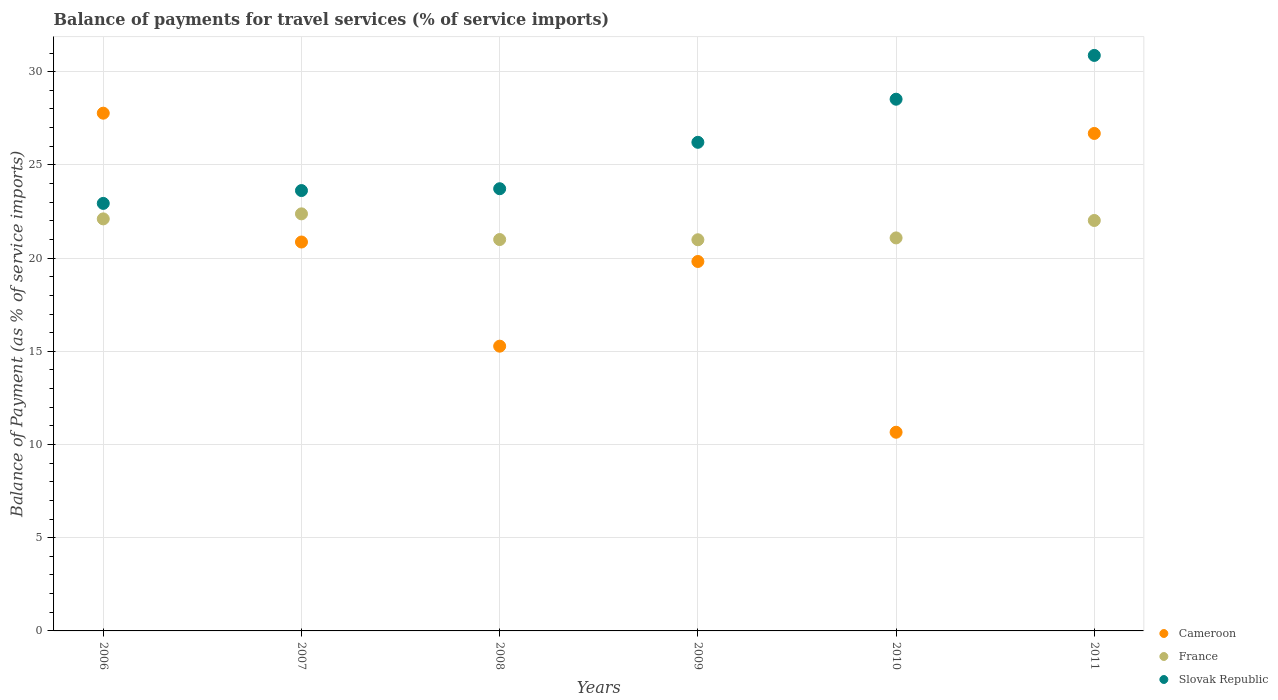Is the number of dotlines equal to the number of legend labels?
Your answer should be compact. Yes. What is the balance of payments for travel services in Cameroon in 2008?
Offer a very short reply. 15.27. Across all years, what is the maximum balance of payments for travel services in France?
Ensure brevity in your answer.  22.37. Across all years, what is the minimum balance of payments for travel services in France?
Your answer should be very brief. 20.98. In which year was the balance of payments for travel services in Slovak Republic minimum?
Keep it short and to the point. 2006. What is the total balance of payments for travel services in France in the graph?
Provide a short and direct response. 129.55. What is the difference between the balance of payments for travel services in France in 2006 and that in 2008?
Give a very brief answer. 1.11. What is the difference between the balance of payments for travel services in Slovak Republic in 2011 and the balance of payments for travel services in Cameroon in 2008?
Provide a short and direct response. 15.6. What is the average balance of payments for travel services in France per year?
Your answer should be very brief. 21.59. In the year 2007, what is the difference between the balance of payments for travel services in France and balance of payments for travel services in Cameroon?
Provide a short and direct response. 1.51. In how many years, is the balance of payments for travel services in Slovak Republic greater than 20 %?
Make the answer very short. 6. What is the ratio of the balance of payments for travel services in Slovak Republic in 2009 to that in 2010?
Offer a terse response. 0.92. Is the balance of payments for travel services in France in 2007 less than that in 2008?
Make the answer very short. No. Is the difference between the balance of payments for travel services in France in 2010 and 2011 greater than the difference between the balance of payments for travel services in Cameroon in 2010 and 2011?
Provide a succinct answer. Yes. What is the difference between the highest and the second highest balance of payments for travel services in Cameroon?
Provide a succinct answer. 1.09. What is the difference between the highest and the lowest balance of payments for travel services in Slovak Republic?
Keep it short and to the point. 7.94. In how many years, is the balance of payments for travel services in France greater than the average balance of payments for travel services in France taken over all years?
Ensure brevity in your answer.  3. Is the sum of the balance of payments for travel services in France in 2007 and 2011 greater than the maximum balance of payments for travel services in Slovak Republic across all years?
Provide a succinct answer. Yes. Is it the case that in every year, the sum of the balance of payments for travel services in Slovak Republic and balance of payments for travel services in Cameroon  is greater than the balance of payments for travel services in France?
Ensure brevity in your answer.  Yes. How many dotlines are there?
Your response must be concise. 3. What is the difference between two consecutive major ticks on the Y-axis?
Keep it short and to the point. 5. Are the values on the major ticks of Y-axis written in scientific E-notation?
Ensure brevity in your answer.  No. Where does the legend appear in the graph?
Your answer should be compact. Bottom right. What is the title of the graph?
Your answer should be very brief. Balance of payments for travel services (% of service imports). What is the label or title of the X-axis?
Your answer should be compact. Years. What is the label or title of the Y-axis?
Your response must be concise. Balance of Payment (as % of service imports). What is the Balance of Payment (as % of service imports) of Cameroon in 2006?
Offer a terse response. 27.77. What is the Balance of Payment (as % of service imports) in France in 2006?
Give a very brief answer. 22.1. What is the Balance of Payment (as % of service imports) of Slovak Republic in 2006?
Give a very brief answer. 22.93. What is the Balance of Payment (as % of service imports) in Cameroon in 2007?
Give a very brief answer. 20.86. What is the Balance of Payment (as % of service imports) in France in 2007?
Your response must be concise. 22.37. What is the Balance of Payment (as % of service imports) of Slovak Republic in 2007?
Your answer should be compact. 23.62. What is the Balance of Payment (as % of service imports) in Cameroon in 2008?
Your response must be concise. 15.27. What is the Balance of Payment (as % of service imports) of France in 2008?
Provide a succinct answer. 20.99. What is the Balance of Payment (as % of service imports) of Slovak Republic in 2008?
Ensure brevity in your answer.  23.72. What is the Balance of Payment (as % of service imports) in Cameroon in 2009?
Provide a succinct answer. 19.82. What is the Balance of Payment (as % of service imports) of France in 2009?
Provide a short and direct response. 20.98. What is the Balance of Payment (as % of service imports) in Slovak Republic in 2009?
Provide a succinct answer. 26.21. What is the Balance of Payment (as % of service imports) of Cameroon in 2010?
Provide a succinct answer. 10.66. What is the Balance of Payment (as % of service imports) in France in 2010?
Offer a terse response. 21.08. What is the Balance of Payment (as % of service imports) of Slovak Republic in 2010?
Offer a terse response. 28.52. What is the Balance of Payment (as % of service imports) in Cameroon in 2011?
Give a very brief answer. 26.69. What is the Balance of Payment (as % of service imports) of France in 2011?
Your answer should be very brief. 22.02. What is the Balance of Payment (as % of service imports) of Slovak Republic in 2011?
Your answer should be very brief. 30.87. Across all years, what is the maximum Balance of Payment (as % of service imports) in Cameroon?
Provide a succinct answer. 27.77. Across all years, what is the maximum Balance of Payment (as % of service imports) in France?
Offer a very short reply. 22.37. Across all years, what is the maximum Balance of Payment (as % of service imports) of Slovak Republic?
Keep it short and to the point. 30.87. Across all years, what is the minimum Balance of Payment (as % of service imports) of Cameroon?
Keep it short and to the point. 10.66. Across all years, what is the minimum Balance of Payment (as % of service imports) in France?
Your answer should be compact. 20.98. Across all years, what is the minimum Balance of Payment (as % of service imports) of Slovak Republic?
Offer a very short reply. 22.93. What is the total Balance of Payment (as % of service imports) of Cameroon in the graph?
Provide a succinct answer. 121.07. What is the total Balance of Payment (as % of service imports) of France in the graph?
Provide a short and direct response. 129.55. What is the total Balance of Payment (as % of service imports) in Slovak Republic in the graph?
Your response must be concise. 155.88. What is the difference between the Balance of Payment (as % of service imports) of Cameroon in 2006 and that in 2007?
Give a very brief answer. 6.91. What is the difference between the Balance of Payment (as % of service imports) of France in 2006 and that in 2007?
Offer a very short reply. -0.27. What is the difference between the Balance of Payment (as % of service imports) of Slovak Republic in 2006 and that in 2007?
Keep it short and to the point. -0.69. What is the difference between the Balance of Payment (as % of service imports) in Cameroon in 2006 and that in 2008?
Offer a very short reply. 12.5. What is the difference between the Balance of Payment (as % of service imports) in France in 2006 and that in 2008?
Make the answer very short. 1.11. What is the difference between the Balance of Payment (as % of service imports) in Slovak Republic in 2006 and that in 2008?
Your response must be concise. -0.79. What is the difference between the Balance of Payment (as % of service imports) of Cameroon in 2006 and that in 2009?
Make the answer very short. 7.96. What is the difference between the Balance of Payment (as % of service imports) of France in 2006 and that in 2009?
Your answer should be very brief. 1.12. What is the difference between the Balance of Payment (as % of service imports) of Slovak Republic in 2006 and that in 2009?
Your response must be concise. -3.28. What is the difference between the Balance of Payment (as % of service imports) of Cameroon in 2006 and that in 2010?
Ensure brevity in your answer.  17.11. What is the difference between the Balance of Payment (as % of service imports) in France in 2006 and that in 2010?
Your answer should be very brief. 1.02. What is the difference between the Balance of Payment (as % of service imports) in Slovak Republic in 2006 and that in 2010?
Provide a succinct answer. -5.59. What is the difference between the Balance of Payment (as % of service imports) in Cameroon in 2006 and that in 2011?
Ensure brevity in your answer.  1.09. What is the difference between the Balance of Payment (as % of service imports) in France in 2006 and that in 2011?
Provide a succinct answer. 0.09. What is the difference between the Balance of Payment (as % of service imports) in Slovak Republic in 2006 and that in 2011?
Offer a terse response. -7.94. What is the difference between the Balance of Payment (as % of service imports) of Cameroon in 2007 and that in 2008?
Your answer should be very brief. 5.59. What is the difference between the Balance of Payment (as % of service imports) in France in 2007 and that in 2008?
Provide a succinct answer. 1.38. What is the difference between the Balance of Payment (as % of service imports) of Slovak Republic in 2007 and that in 2008?
Offer a very short reply. -0.1. What is the difference between the Balance of Payment (as % of service imports) of Cameroon in 2007 and that in 2009?
Give a very brief answer. 1.04. What is the difference between the Balance of Payment (as % of service imports) in France in 2007 and that in 2009?
Your answer should be compact. 1.39. What is the difference between the Balance of Payment (as % of service imports) in Slovak Republic in 2007 and that in 2009?
Keep it short and to the point. -2.59. What is the difference between the Balance of Payment (as % of service imports) in Cameroon in 2007 and that in 2010?
Make the answer very short. 10.2. What is the difference between the Balance of Payment (as % of service imports) in France in 2007 and that in 2010?
Offer a terse response. 1.29. What is the difference between the Balance of Payment (as % of service imports) of Slovak Republic in 2007 and that in 2010?
Offer a terse response. -4.9. What is the difference between the Balance of Payment (as % of service imports) of Cameroon in 2007 and that in 2011?
Offer a very short reply. -5.82. What is the difference between the Balance of Payment (as % of service imports) in France in 2007 and that in 2011?
Your answer should be very brief. 0.36. What is the difference between the Balance of Payment (as % of service imports) in Slovak Republic in 2007 and that in 2011?
Offer a terse response. -7.25. What is the difference between the Balance of Payment (as % of service imports) of Cameroon in 2008 and that in 2009?
Provide a short and direct response. -4.54. What is the difference between the Balance of Payment (as % of service imports) in France in 2008 and that in 2009?
Offer a terse response. 0.01. What is the difference between the Balance of Payment (as % of service imports) in Slovak Republic in 2008 and that in 2009?
Offer a terse response. -2.49. What is the difference between the Balance of Payment (as % of service imports) in Cameroon in 2008 and that in 2010?
Offer a terse response. 4.62. What is the difference between the Balance of Payment (as % of service imports) of France in 2008 and that in 2010?
Provide a succinct answer. -0.09. What is the difference between the Balance of Payment (as % of service imports) in Slovak Republic in 2008 and that in 2010?
Keep it short and to the point. -4.8. What is the difference between the Balance of Payment (as % of service imports) in Cameroon in 2008 and that in 2011?
Keep it short and to the point. -11.41. What is the difference between the Balance of Payment (as % of service imports) of France in 2008 and that in 2011?
Ensure brevity in your answer.  -1.02. What is the difference between the Balance of Payment (as % of service imports) of Slovak Republic in 2008 and that in 2011?
Make the answer very short. -7.15. What is the difference between the Balance of Payment (as % of service imports) in Cameroon in 2009 and that in 2010?
Keep it short and to the point. 9.16. What is the difference between the Balance of Payment (as % of service imports) of France in 2009 and that in 2010?
Your answer should be compact. -0.1. What is the difference between the Balance of Payment (as % of service imports) in Slovak Republic in 2009 and that in 2010?
Give a very brief answer. -2.31. What is the difference between the Balance of Payment (as % of service imports) of Cameroon in 2009 and that in 2011?
Your answer should be very brief. -6.87. What is the difference between the Balance of Payment (as % of service imports) of France in 2009 and that in 2011?
Give a very brief answer. -1.03. What is the difference between the Balance of Payment (as % of service imports) of Slovak Republic in 2009 and that in 2011?
Ensure brevity in your answer.  -4.66. What is the difference between the Balance of Payment (as % of service imports) in Cameroon in 2010 and that in 2011?
Give a very brief answer. -16.03. What is the difference between the Balance of Payment (as % of service imports) in France in 2010 and that in 2011?
Your answer should be very brief. -0.93. What is the difference between the Balance of Payment (as % of service imports) in Slovak Republic in 2010 and that in 2011?
Your answer should be compact. -2.35. What is the difference between the Balance of Payment (as % of service imports) of Cameroon in 2006 and the Balance of Payment (as % of service imports) of France in 2007?
Offer a terse response. 5.4. What is the difference between the Balance of Payment (as % of service imports) in Cameroon in 2006 and the Balance of Payment (as % of service imports) in Slovak Republic in 2007?
Provide a succinct answer. 4.15. What is the difference between the Balance of Payment (as % of service imports) of France in 2006 and the Balance of Payment (as % of service imports) of Slovak Republic in 2007?
Offer a terse response. -1.52. What is the difference between the Balance of Payment (as % of service imports) of Cameroon in 2006 and the Balance of Payment (as % of service imports) of France in 2008?
Make the answer very short. 6.78. What is the difference between the Balance of Payment (as % of service imports) of Cameroon in 2006 and the Balance of Payment (as % of service imports) of Slovak Republic in 2008?
Your response must be concise. 4.05. What is the difference between the Balance of Payment (as % of service imports) in France in 2006 and the Balance of Payment (as % of service imports) in Slovak Republic in 2008?
Ensure brevity in your answer.  -1.62. What is the difference between the Balance of Payment (as % of service imports) in Cameroon in 2006 and the Balance of Payment (as % of service imports) in France in 2009?
Your answer should be compact. 6.79. What is the difference between the Balance of Payment (as % of service imports) in Cameroon in 2006 and the Balance of Payment (as % of service imports) in Slovak Republic in 2009?
Your response must be concise. 1.56. What is the difference between the Balance of Payment (as % of service imports) in France in 2006 and the Balance of Payment (as % of service imports) in Slovak Republic in 2009?
Offer a very short reply. -4.11. What is the difference between the Balance of Payment (as % of service imports) of Cameroon in 2006 and the Balance of Payment (as % of service imports) of France in 2010?
Your answer should be compact. 6.69. What is the difference between the Balance of Payment (as % of service imports) in Cameroon in 2006 and the Balance of Payment (as % of service imports) in Slovak Republic in 2010?
Make the answer very short. -0.75. What is the difference between the Balance of Payment (as % of service imports) of France in 2006 and the Balance of Payment (as % of service imports) of Slovak Republic in 2010?
Offer a very short reply. -6.42. What is the difference between the Balance of Payment (as % of service imports) of Cameroon in 2006 and the Balance of Payment (as % of service imports) of France in 2011?
Make the answer very short. 5.76. What is the difference between the Balance of Payment (as % of service imports) in Cameroon in 2006 and the Balance of Payment (as % of service imports) in Slovak Republic in 2011?
Make the answer very short. -3.1. What is the difference between the Balance of Payment (as % of service imports) in France in 2006 and the Balance of Payment (as % of service imports) in Slovak Republic in 2011?
Offer a very short reply. -8.77. What is the difference between the Balance of Payment (as % of service imports) of Cameroon in 2007 and the Balance of Payment (as % of service imports) of France in 2008?
Provide a short and direct response. -0.13. What is the difference between the Balance of Payment (as % of service imports) in Cameroon in 2007 and the Balance of Payment (as % of service imports) in Slovak Republic in 2008?
Keep it short and to the point. -2.86. What is the difference between the Balance of Payment (as % of service imports) of France in 2007 and the Balance of Payment (as % of service imports) of Slovak Republic in 2008?
Your response must be concise. -1.35. What is the difference between the Balance of Payment (as % of service imports) of Cameroon in 2007 and the Balance of Payment (as % of service imports) of France in 2009?
Your answer should be compact. -0.12. What is the difference between the Balance of Payment (as % of service imports) of Cameroon in 2007 and the Balance of Payment (as % of service imports) of Slovak Republic in 2009?
Provide a short and direct response. -5.35. What is the difference between the Balance of Payment (as % of service imports) in France in 2007 and the Balance of Payment (as % of service imports) in Slovak Republic in 2009?
Make the answer very short. -3.84. What is the difference between the Balance of Payment (as % of service imports) of Cameroon in 2007 and the Balance of Payment (as % of service imports) of France in 2010?
Offer a terse response. -0.22. What is the difference between the Balance of Payment (as % of service imports) of Cameroon in 2007 and the Balance of Payment (as % of service imports) of Slovak Republic in 2010?
Your answer should be very brief. -7.66. What is the difference between the Balance of Payment (as % of service imports) of France in 2007 and the Balance of Payment (as % of service imports) of Slovak Republic in 2010?
Provide a succinct answer. -6.15. What is the difference between the Balance of Payment (as % of service imports) in Cameroon in 2007 and the Balance of Payment (as % of service imports) in France in 2011?
Make the answer very short. -1.16. What is the difference between the Balance of Payment (as % of service imports) of Cameroon in 2007 and the Balance of Payment (as % of service imports) of Slovak Republic in 2011?
Your response must be concise. -10.01. What is the difference between the Balance of Payment (as % of service imports) of France in 2007 and the Balance of Payment (as % of service imports) of Slovak Republic in 2011?
Your response must be concise. -8.5. What is the difference between the Balance of Payment (as % of service imports) in Cameroon in 2008 and the Balance of Payment (as % of service imports) in France in 2009?
Offer a very short reply. -5.71. What is the difference between the Balance of Payment (as % of service imports) of Cameroon in 2008 and the Balance of Payment (as % of service imports) of Slovak Republic in 2009?
Your response must be concise. -10.94. What is the difference between the Balance of Payment (as % of service imports) in France in 2008 and the Balance of Payment (as % of service imports) in Slovak Republic in 2009?
Ensure brevity in your answer.  -5.22. What is the difference between the Balance of Payment (as % of service imports) in Cameroon in 2008 and the Balance of Payment (as % of service imports) in France in 2010?
Keep it short and to the point. -5.81. What is the difference between the Balance of Payment (as % of service imports) of Cameroon in 2008 and the Balance of Payment (as % of service imports) of Slovak Republic in 2010?
Your response must be concise. -13.25. What is the difference between the Balance of Payment (as % of service imports) of France in 2008 and the Balance of Payment (as % of service imports) of Slovak Republic in 2010?
Your answer should be very brief. -7.53. What is the difference between the Balance of Payment (as % of service imports) in Cameroon in 2008 and the Balance of Payment (as % of service imports) in France in 2011?
Offer a terse response. -6.74. What is the difference between the Balance of Payment (as % of service imports) of Cameroon in 2008 and the Balance of Payment (as % of service imports) of Slovak Republic in 2011?
Provide a short and direct response. -15.6. What is the difference between the Balance of Payment (as % of service imports) in France in 2008 and the Balance of Payment (as % of service imports) in Slovak Republic in 2011?
Offer a very short reply. -9.88. What is the difference between the Balance of Payment (as % of service imports) of Cameroon in 2009 and the Balance of Payment (as % of service imports) of France in 2010?
Provide a short and direct response. -1.26. What is the difference between the Balance of Payment (as % of service imports) of Cameroon in 2009 and the Balance of Payment (as % of service imports) of Slovak Republic in 2010?
Your response must be concise. -8.7. What is the difference between the Balance of Payment (as % of service imports) of France in 2009 and the Balance of Payment (as % of service imports) of Slovak Republic in 2010?
Provide a short and direct response. -7.54. What is the difference between the Balance of Payment (as % of service imports) in Cameroon in 2009 and the Balance of Payment (as % of service imports) in France in 2011?
Provide a short and direct response. -2.2. What is the difference between the Balance of Payment (as % of service imports) of Cameroon in 2009 and the Balance of Payment (as % of service imports) of Slovak Republic in 2011?
Your answer should be very brief. -11.05. What is the difference between the Balance of Payment (as % of service imports) of France in 2009 and the Balance of Payment (as % of service imports) of Slovak Republic in 2011?
Your answer should be compact. -9.89. What is the difference between the Balance of Payment (as % of service imports) in Cameroon in 2010 and the Balance of Payment (as % of service imports) in France in 2011?
Your answer should be very brief. -11.36. What is the difference between the Balance of Payment (as % of service imports) in Cameroon in 2010 and the Balance of Payment (as % of service imports) in Slovak Republic in 2011?
Provide a short and direct response. -20.21. What is the difference between the Balance of Payment (as % of service imports) of France in 2010 and the Balance of Payment (as % of service imports) of Slovak Republic in 2011?
Offer a very short reply. -9.79. What is the average Balance of Payment (as % of service imports) of Cameroon per year?
Give a very brief answer. 20.18. What is the average Balance of Payment (as % of service imports) in France per year?
Offer a terse response. 21.59. What is the average Balance of Payment (as % of service imports) in Slovak Republic per year?
Make the answer very short. 25.98. In the year 2006, what is the difference between the Balance of Payment (as % of service imports) in Cameroon and Balance of Payment (as % of service imports) in France?
Your response must be concise. 5.67. In the year 2006, what is the difference between the Balance of Payment (as % of service imports) in Cameroon and Balance of Payment (as % of service imports) in Slovak Republic?
Your answer should be very brief. 4.84. In the year 2006, what is the difference between the Balance of Payment (as % of service imports) of France and Balance of Payment (as % of service imports) of Slovak Republic?
Your answer should be compact. -0.83. In the year 2007, what is the difference between the Balance of Payment (as % of service imports) in Cameroon and Balance of Payment (as % of service imports) in France?
Your response must be concise. -1.51. In the year 2007, what is the difference between the Balance of Payment (as % of service imports) of Cameroon and Balance of Payment (as % of service imports) of Slovak Republic?
Offer a very short reply. -2.76. In the year 2007, what is the difference between the Balance of Payment (as % of service imports) of France and Balance of Payment (as % of service imports) of Slovak Republic?
Keep it short and to the point. -1.25. In the year 2008, what is the difference between the Balance of Payment (as % of service imports) of Cameroon and Balance of Payment (as % of service imports) of France?
Make the answer very short. -5.72. In the year 2008, what is the difference between the Balance of Payment (as % of service imports) of Cameroon and Balance of Payment (as % of service imports) of Slovak Republic?
Offer a very short reply. -8.45. In the year 2008, what is the difference between the Balance of Payment (as % of service imports) in France and Balance of Payment (as % of service imports) in Slovak Republic?
Offer a terse response. -2.73. In the year 2009, what is the difference between the Balance of Payment (as % of service imports) of Cameroon and Balance of Payment (as % of service imports) of France?
Offer a very short reply. -1.17. In the year 2009, what is the difference between the Balance of Payment (as % of service imports) of Cameroon and Balance of Payment (as % of service imports) of Slovak Republic?
Your answer should be compact. -6.39. In the year 2009, what is the difference between the Balance of Payment (as % of service imports) of France and Balance of Payment (as % of service imports) of Slovak Republic?
Keep it short and to the point. -5.23. In the year 2010, what is the difference between the Balance of Payment (as % of service imports) of Cameroon and Balance of Payment (as % of service imports) of France?
Offer a terse response. -10.42. In the year 2010, what is the difference between the Balance of Payment (as % of service imports) in Cameroon and Balance of Payment (as % of service imports) in Slovak Republic?
Provide a succinct answer. -17.86. In the year 2010, what is the difference between the Balance of Payment (as % of service imports) of France and Balance of Payment (as % of service imports) of Slovak Republic?
Offer a terse response. -7.44. In the year 2011, what is the difference between the Balance of Payment (as % of service imports) of Cameroon and Balance of Payment (as % of service imports) of France?
Give a very brief answer. 4.67. In the year 2011, what is the difference between the Balance of Payment (as % of service imports) in Cameroon and Balance of Payment (as % of service imports) in Slovak Republic?
Offer a terse response. -4.19. In the year 2011, what is the difference between the Balance of Payment (as % of service imports) in France and Balance of Payment (as % of service imports) in Slovak Republic?
Give a very brief answer. -8.85. What is the ratio of the Balance of Payment (as % of service imports) of Cameroon in 2006 to that in 2007?
Your response must be concise. 1.33. What is the ratio of the Balance of Payment (as % of service imports) in France in 2006 to that in 2007?
Make the answer very short. 0.99. What is the ratio of the Balance of Payment (as % of service imports) of Slovak Republic in 2006 to that in 2007?
Your answer should be very brief. 0.97. What is the ratio of the Balance of Payment (as % of service imports) in Cameroon in 2006 to that in 2008?
Keep it short and to the point. 1.82. What is the ratio of the Balance of Payment (as % of service imports) in France in 2006 to that in 2008?
Give a very brief answer. 1.05. What is the ratio of the Balance of Payment (as % of service imports) of Slovak Republic in 2006 to that in 2008?
Provide a short and direct response. 0.97. What is the ratio of the Balance of Payment (as % of service imports) in Cameroon in 2006 to that in 2009?
Offer a terse response. 1.4. What is the ratio of the Balance of Payment (as % of service imports) in France in 2006 to that in 2009?
Give a very brief answer. 1.05. What is the ratio of the Balance of Payment (as % of service imports) of Slovak Republic in 2006 to that in 2009?
Your answer should be very brief. 0.88. What is the ratio of the Balance of Payment (as % of service imports) in Cameroon in 2006 to that in 2010?
Ensure brevity in your answer.  2.61. What is the ratio of the Balance of Payment (as % of service imports) of France in 2006 to that in 2010?
Offer a terse response. 1.05. What is the ratio of the Balance of Payment (as % of service imports) of Slovak Republic in 2006 to that in 2010?
Make the answer very short. 0.8. What is the ratio of the Balance of Payment (as % of service imports) in Cameroon in 2006 to that in 2011?
Make the answer very short. 1.04. What is the ratio of the Balance of Payment (as % of service imports) in France in 2006 to that in 2011?
Your answer should be very brief. 1. What is the ratio of the Balance of Payment (as % of service imports) in Slovak Republic in 2006 to that in 2011?
Ensure brevity in your answer.  0.74. What is the ratio of the Balance of Payment (as % of service imports) in Cameroon in 2007 to that in 2008?
Offer a very short reply. 1.37. What is the ratio of the Balance of Payment (as % of service imports) of France in 2007 to that in 2008?
Your response must be concise. 1.07. What is the ratio of the Balance of Payment (as % of service imports) in Slovak Republic in 2007 to that in 2008?
Give a very brief answer. 1. What is the ratio of the Balance of Payment (as % of service imports) of Cameroon in 2007 to that in 2009?
Give a very brief answer. 1.05. What is the ratio of the Balance of Payment (as % of service imports) of France in 2007 to that in 2009?
Make the answer very short. 1.07. What is the ratio of the Balance of Payment (as % of service imports) in Slovak Republic in 2007 to that in 2009?
Offer a very short reply. 0.9. What is the ratio of the Balance of Payment (as % of service imports) of Cameroon in 2007 to that in 2010?
Offer a terse response. 1.96. What is the ratio of the Balance of Payment (as % of service imports) of France in 2007 to that in 2010?
Provide a short and direct response. 1.06. What is the ratio of the Balance of Payment (as % of service imports) in Slovak Republic in 2007 to that in 2010?
Ensure brevity in your answer.  0.83. What is the ratio of the Balance of Payment (as % of service imports) of Cameroon in 2007 to that in 2011?
Provide a succinct answer. 0.78. What is the ratio of the Balance of Payment (as % of service imports) of France in 2007 to that in 2011?
Offer a terse response. 1.02. What is the ratio of the Balance of Payment (as % of service imports) of Slovak Republic in 2007 to that in 2011?
Provide a short and direct response. 0.77. What is the ratio of the Balance of Payment (as % of service imports) in Cameroon in 2008 to that in 2009?
Offer a very short reply. 0.77. What is the ratio of the Balance of Payment (as % of service imports) in Slovak Republic in 2008 to that in 2009?
Give a very brief answer. 0.91. What is the ratio of the Balance of Payment (as % of service imports) of Cameroon in 2008 to that in 2010?
Ensure brevity in your answer.  1.43. What is the ratio of the Balance of Payment (as % of service imports) of France in 2008 to that in 2010?
Ensure brevity in your answer.  1. What is the ratio of the Balance of Payment (as % of service imports) of Slovak Republic in 2008 to that in 2010?
Offer a very short reply. 0.83. What is the ratio of the Balance of Payment (as % of service imports) of Cameroon in 2008 to that in 2011?
Provide a succinct answer. 0.57. What is the ratio of the Balance of Payment (as % of service imports) of France in 2008 to that in 2011?
Give a very brief answer. 0.95. What is the ratio of the Balance of Payment (as % of service imports) in Slovak Republic in 2008 to that in 2011?
Give a very brief answer. 0.77. What is the ratio of the Balance of Payment (as % of service imports) of Cameroon in 2009 to that in 2010?
Give a very brief answer. 1.86. What is the ratio of the Balance of Payment (as % of service imports) in France in 2009 to that in 2010?
Your response must be concise. 1. What is the ratio of the Balance of Payment (as % of service imports) in Slovak Republic in 2009 to that in 2010?
Your answer should be very brief. 0.92. What is the ratio of the Balance of Payment (as % of service imports) of Cameroon in 2009 to that in 2011?
Make the answer very short. 0.74. What is the ratio of the Balance of Payment (as % of service imports) of France in 2009 to that in 2011?
Give a very brief answer. 0.95. What is the ratio of the Balance of Payment (as % of service imports) in Slovak Republic in 2009 to that in 2011?
Offer a very short reply. 0.85. What is the ratio of the Balance of Payment (as % of service imports) in Cameroon in 2010 to that in 2011?
Your answer should be compact. 0.4. What is the ratio of the Balance of Payment (as % of service imports) of France in 2010 to that in 2011?
Keep it short and to the point. 0.96. What is the ratio of the Balance of Payment (as % of service imports) in Slovak Republic in 2010 to that in 2011?
Give a very brief answer. 0.92. What is the difference between the highest and the second highest Balance of Payment (as % of service imports) in Cameroon?
Keep it short and to the point. 1.09. What is the difference between the highest and the second highest Balance of Payment (as % of service imports) of France?
Provide a succinct answer. 0.27. What is the difference between the highest and the second highest Balance of Payment (as % of service imports) of Slovak Republic?
Your answer should be very brief. 2.35. What is the difference between the highest and the lowest Balance of Payment (as % of service imports) in Cameroon?
Your response must be concise. 17.11. What is the difference between the highest and the lowest Balance of Payment (as % of service imports) in France?
Ensure brevity in your answer.  1.39. What is the difference between the highest and the lowest Balance of Payment (as % of service imports) of Slovak Republic?
Keep it short and to the point. 7.94. 